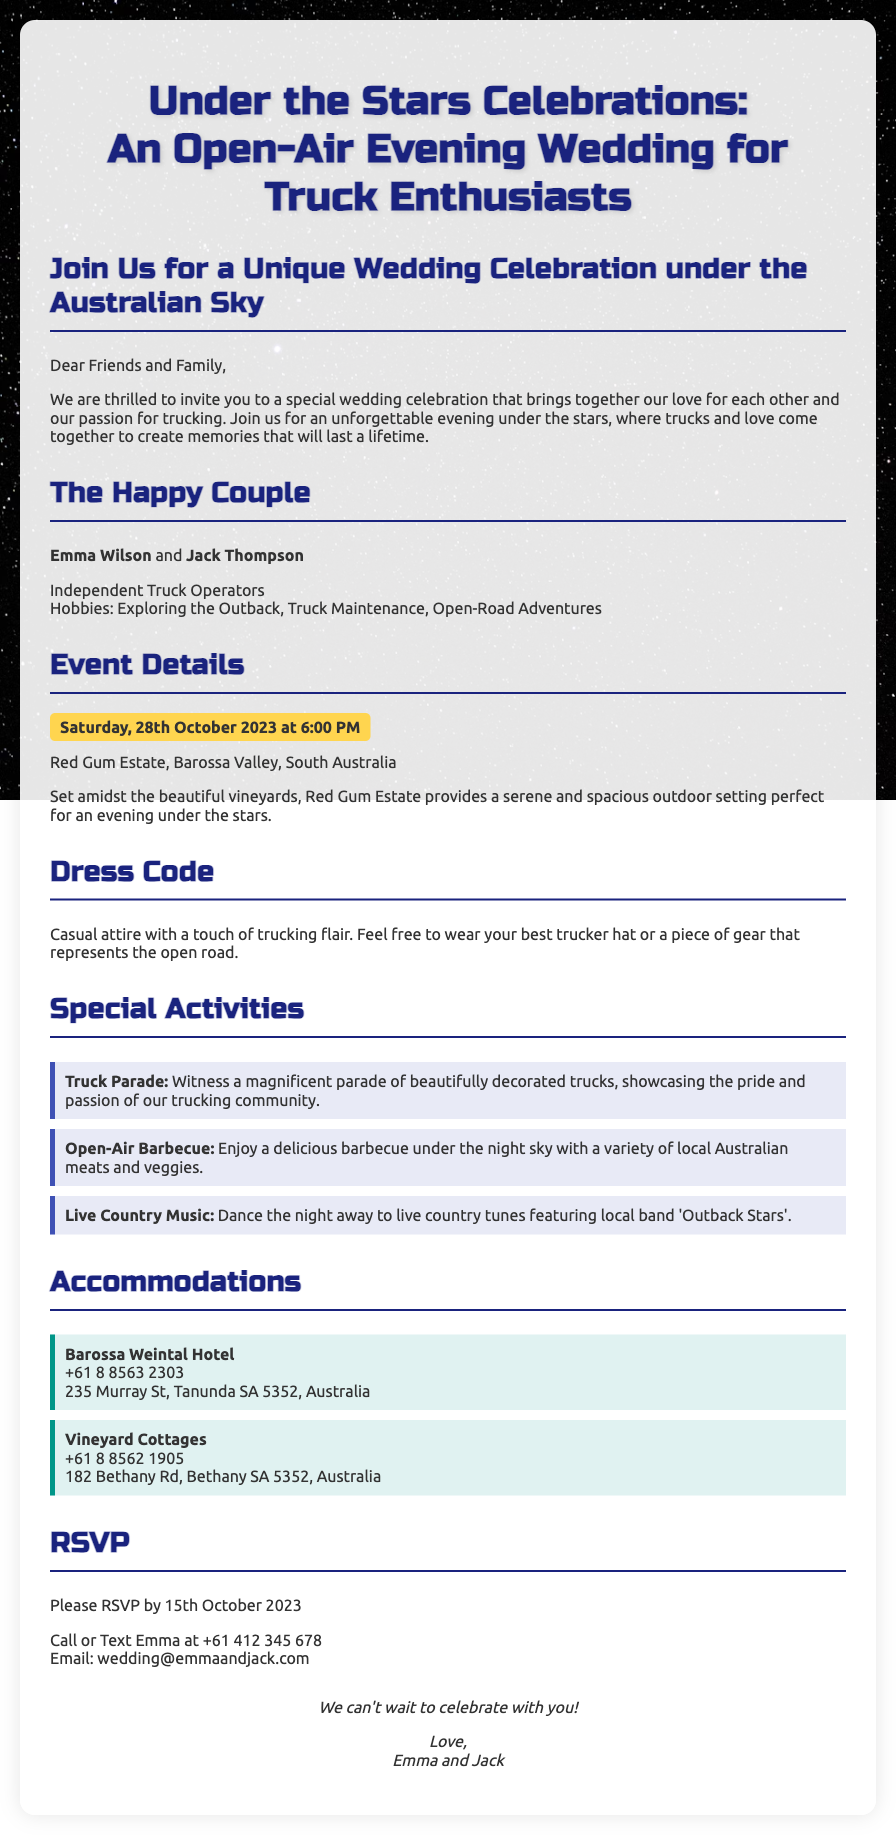What is the date of the wedding? The wedding will take place on Saturday, 28th October 2023.
Answer: Saturday, 28th October 2023 What is the location of the wedding? The wedding will be held at Red Gum Estate, Barossa Valley, South Australia.
Answer: Red Gum Estate, Barossa Valley, South Australia Who are the couple getting married? The names of the couple getting married are Emma Wilson and Jack Thompson.
Answer: Emma Wilson and Jack Thompson What type of clothing is suggested for guests? The dress code encourages casual attire with a touch of trucking flair.
Answer: Casual attire with a touch of trucking flair What activities will be featured at the wedding? There will be a Truck Parade, Open-Air Barbecue, and Live Country Music at the wedding.
Answer: Truck Parade, Open-Air Barbecue, Live Country Music When is the RSVP deadline? Guests are asked to RSVP by 15th October 2023.
Answer: 15th October 2023 What is the contact number for Emma? Guests can contact Emma at +61 412 345 678.
Answer: +61 412 345 678 Is there a specific theme for the wedding? Yes, the theme is focused on trucking enthusiasts combined with an evening celebration under the stars.
Answer: Trucking enthusiasts under the stars 